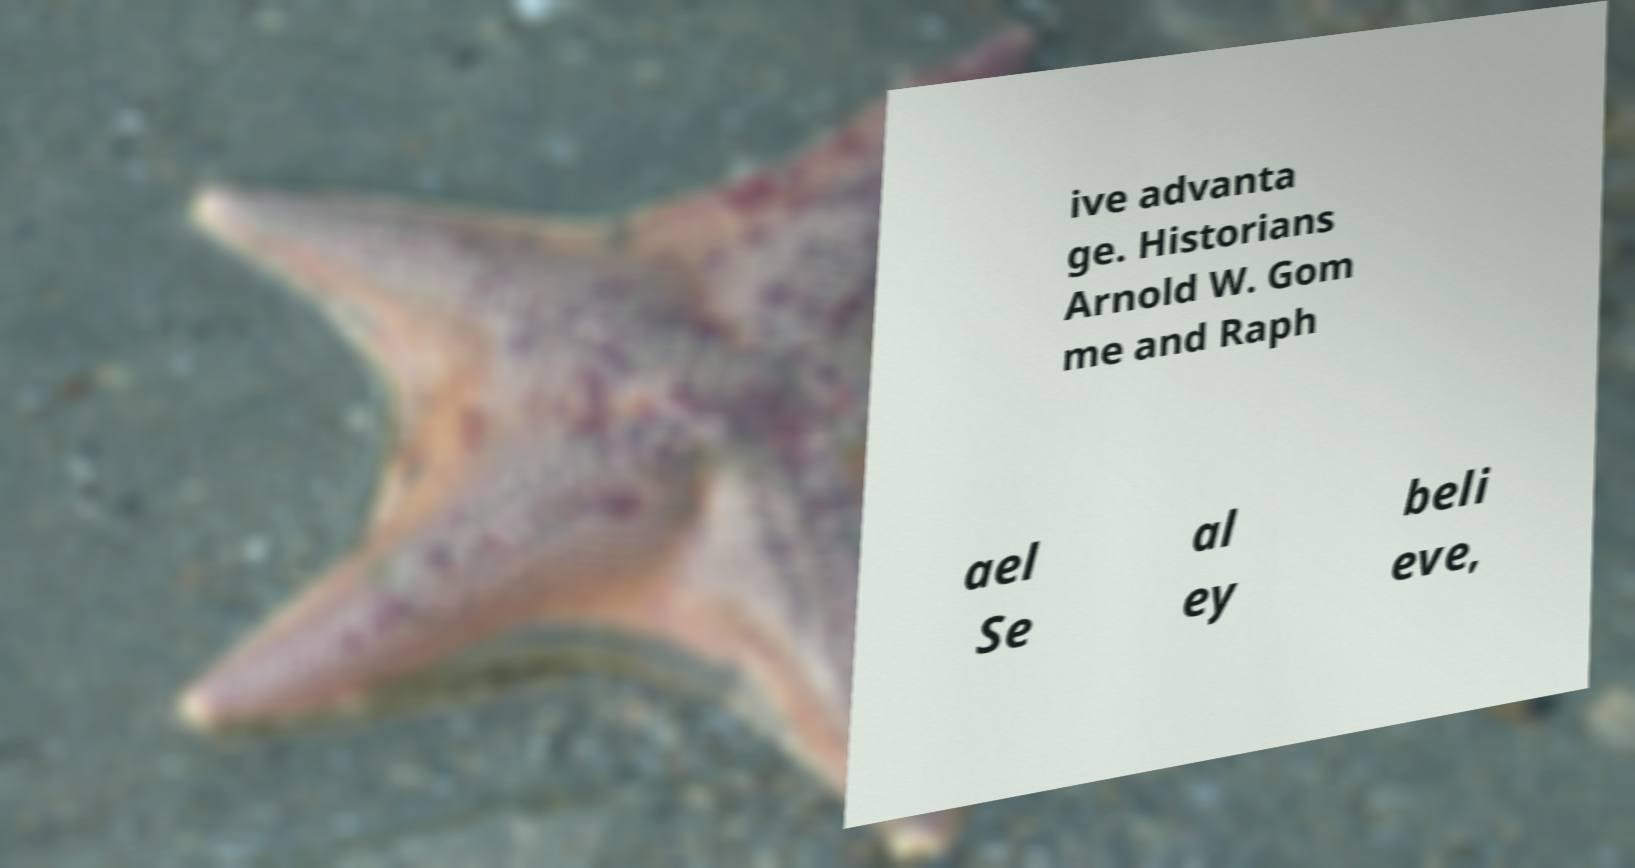What messages or text are displayed in this image? I need them in a readable, typed format. ive advanta ge. Historians Arnold W. Gom me and Raph ael Se al ey beli eve, 